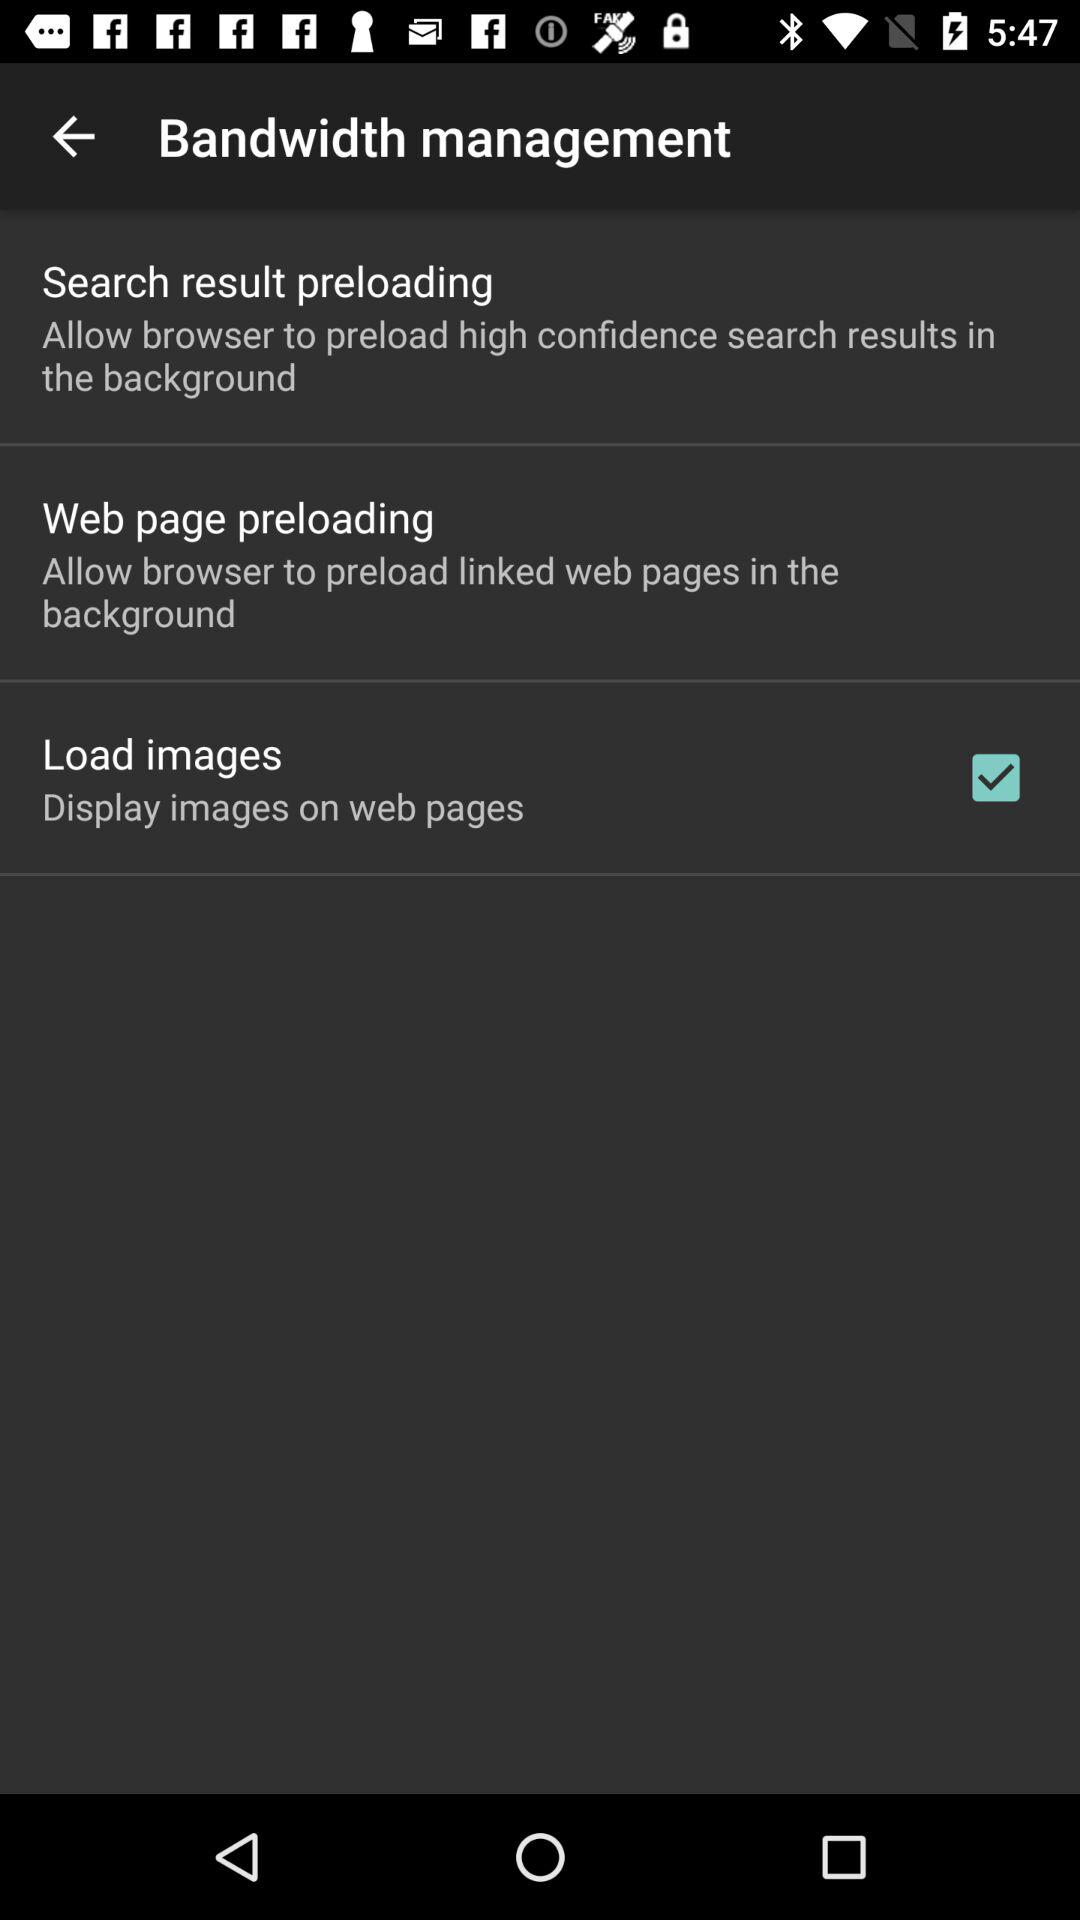What is the status of "Load images"? The status is "on". 